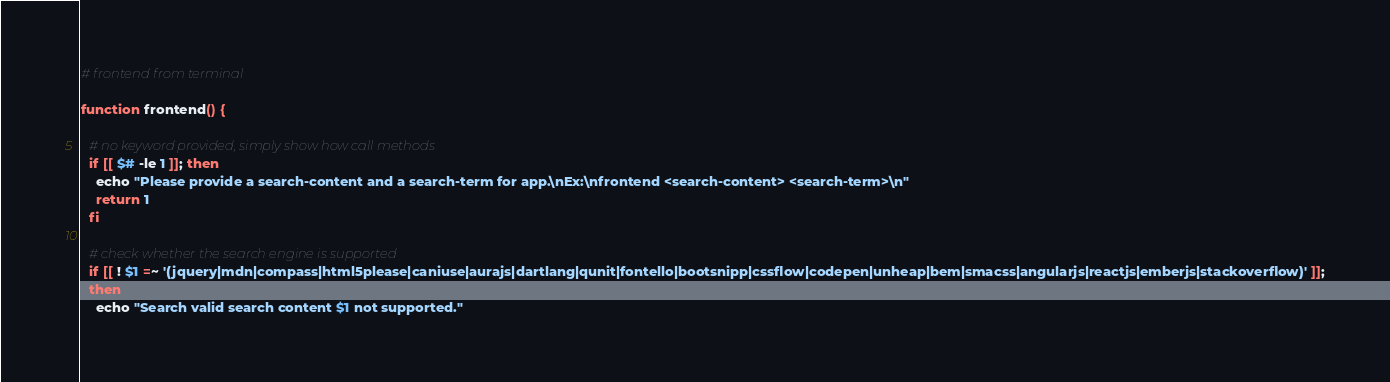<code> <loc_0><loc_0><loc_500><loc_500><_Bash_># frontend from terminal

function frontend() {

  # no keyword provided, simply show how call methods
  if [[ $# -le 1 ]]; then
    echo "Please provide a search-content and a search-term for app.\nEx:\nfrontend <search-content> <search-term>\n"
    return 1
  fi

  # check whether the search engine is supported
  if [[ ! $1 =~ '(jquery|mdn|compass|html5please|caniuse|aurajs|dartlang|qunit|fontello|bootsnipp|cssflow|codepen|unheap|bem|smacss|angularjs|reactjs|emberjs|stackoverflow)' ]];
  then
    echo "Search valid search content $1 not supported."</code> 